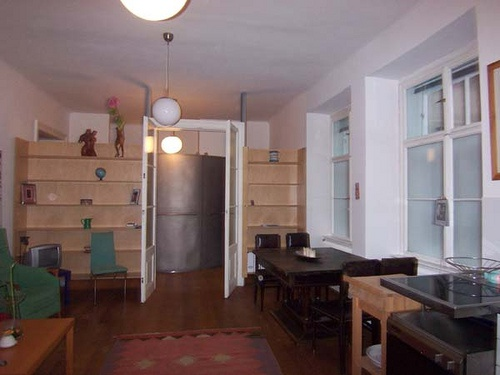Describe the objects in this image and their specific colors. I can see chair in gray, black, and darkgreen tones, dining table in gray, black, and darkgray tones, chair in gray and black tones, chair in gray, teal, black, and maroon tones, and chair in gray and black tones in this image. 